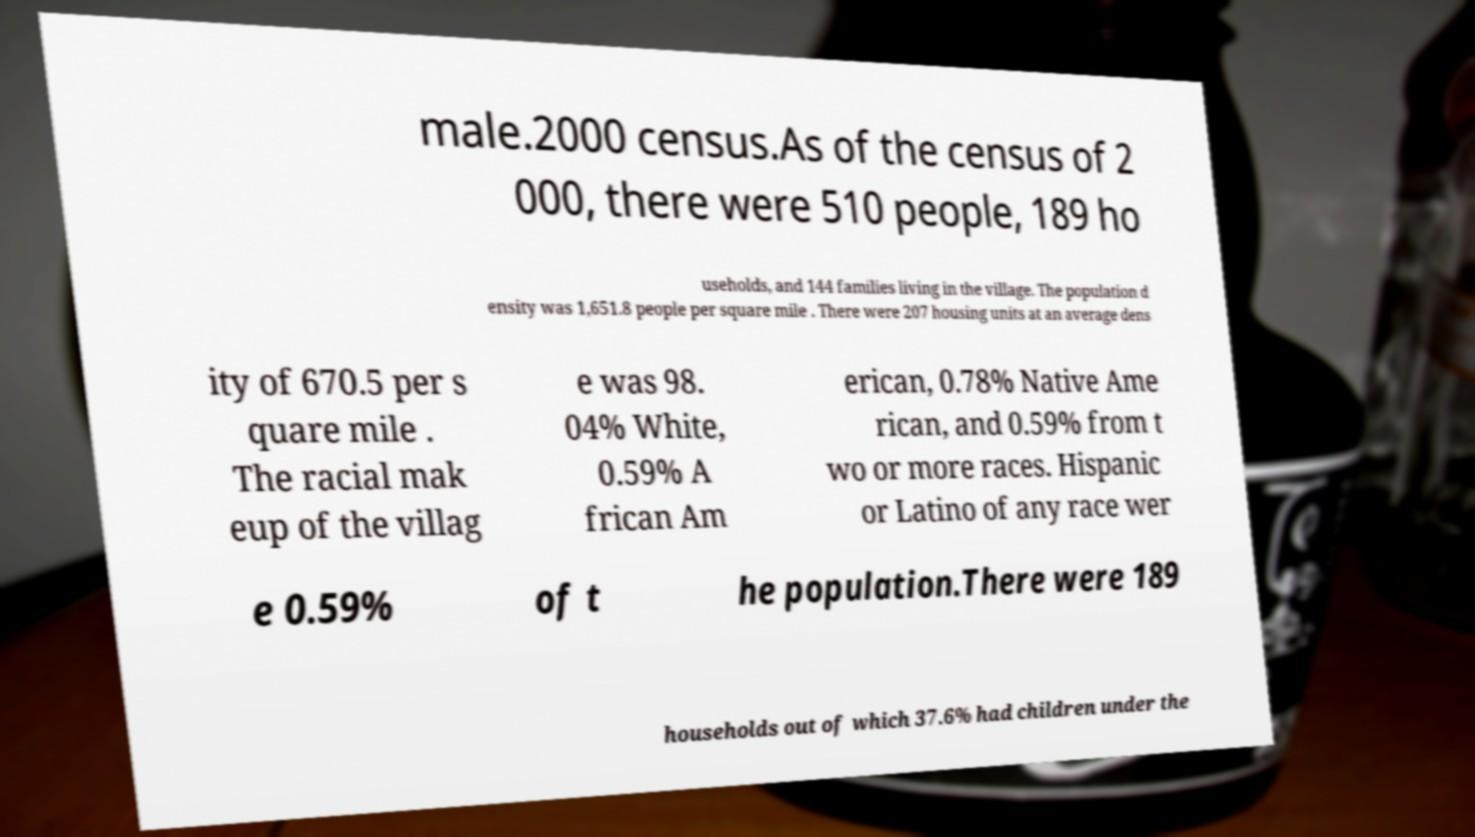What messages or text are displayed in this image? I need them in a readable, typed format. male.2000 census.As of the census of 2 000, there were 510 people, 189 ho useholds, and 144 families living in the village. The population d ensity was 1,651.8 people per square mile . There were 207 housing units at an average dens ity of 670.5 per s quare mile . The racial mak eup of the villag e was 98. 04% White, 0.59% A frican Am erican, 0.78% Native Ame rican, and 0.59% from t wo or more races. Hispanic or Latino of any race wer e 0.59% of t he population.There were 189 households out of which 37.6% had children under the 